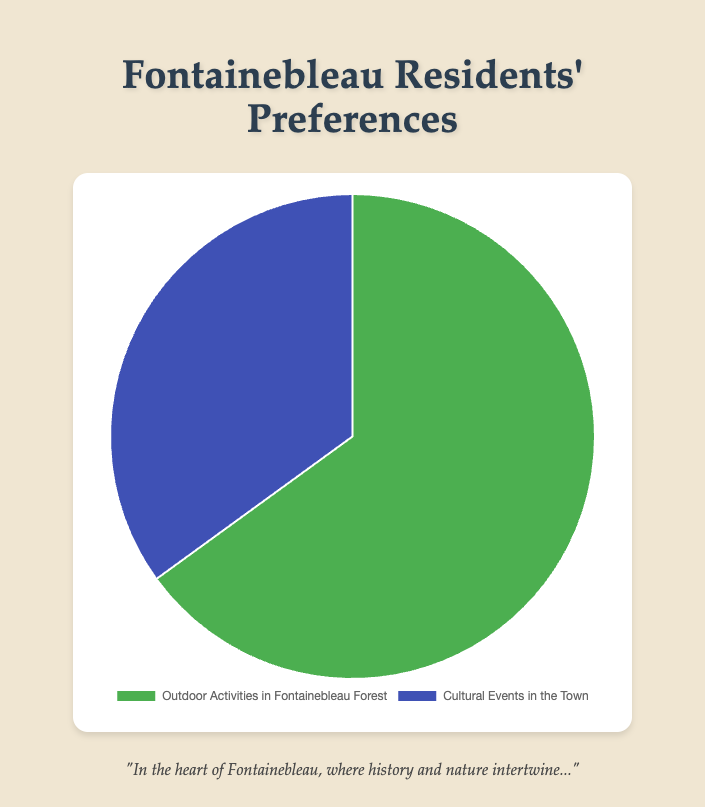What is the percentage of residents who prefer outdoor activities in Fontainebleau Forest? The figure shows that the segment for Outdoor Activities in Fontainebleau Forest covers 65% of the pie chart.
Answer: 65% What percentage of residents prefer cultural events in the town? By looking at the figure, we can see that the segment for Cultural Events in the Town accounts for 35% of the pie chart.
Answer: 35% Which preference has a higher percentage, and by how much? Comparing the two segments, Outdoor Activities in Fontainebleau Forest (65%) is higher than Cultural Events in the Town (35%). The difference is 65% - 35% = 30%.
Answer: Outdoor Activities by 30% If the total number of residents is 1,000, how many prefer each activity? Calculating based on the given percentages: 65% of 1,000 for outdoor activities and 35% of 1,000 for cultural events. So, 0.65 * 1,000 = 650 and 0.35 * 1,000 = 350.
Answer: 650 prefer outdoor activities, 350 prefer cultural events What is the ratio of residents who prefer outdoor activities to those who prefer cultural events? The ratio is determined by dividing the percentage of outdoor activities by the percentage of cultural events: 65% / 35% = 1.857 (approximately).
Answer: 1.857:1 If the percentage for outdoor activities decreased by 5%, what would the new percentages be? Subtract 5% from Outdoor Activities (65% - 5% = 60%) and add this 5% to Cultural Events (35% + 5% = 40%).
Answer: 60% outdoor, 40% cultural events What fraction of the pie chart represents cultural events? The fraction is the percent value over 100, so 35/100 or simplified, 7/20.
Answer: 7/20 How much larger is the green segment compared to the blue segment? The green segment represents 65%, and the blue segment represents 35%. The green segment is 65% - 35% = 30% larger.
Answer: 30% Estimate the angle representing cultural events on the pie chart. A full pie chart is 360 degrees. The proportion for cultural events is 35%, so the angle is 0.35 * 360 = 126 degrees.
Answer: 126 degrees In what color is the segment representing outdoor activities shown? The segment representing Outdoor Activities in Fontainebleau Forest is shown in green.
Answer: Green 